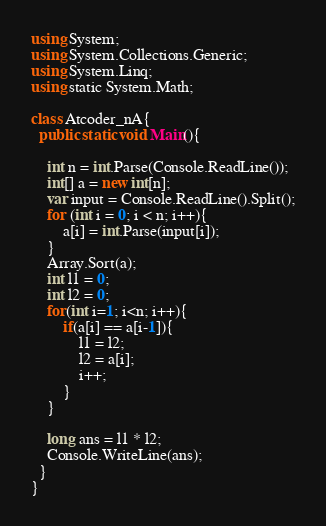<code> <loc_0><loc_0><loc_500><loc_500><_C#_>using System;
using System.Collections.Generic;
using System.Linq;
using static System.Math;

class Atcoder_nA{
  public static void Main(){

    int n = int.Parse(Console.ReadLine());
    int[] a = new int[n];
    var input = Console.ReadLine().Split();
    for (int i = 0; i < n; i++){
        a[i] = int.Parse(input[i]);
    }
    Array.Sort(a);
    int l1 = 0;
    int l2 = 0;
    for(int i=1; i<n; i++){
        if(a[i] == a[i-1]){
            l1 = l2;
            l2 = a[i];
            i++;
        }
    }

    long ans = l1 * l2;
    Console.WriteLine(ans);
  }
}</code> 